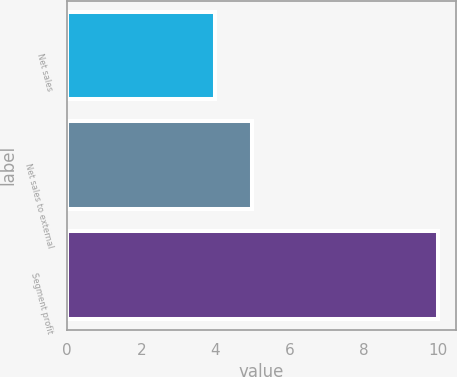<chart> <loc_0><loc_0><loc_500><loc_500><bar_chart><fcel>Net sales<fcel>Net sales to external<fcel>Segment profit<nl><fcel>4<fcel>5<fcel>10<nl></chart> 